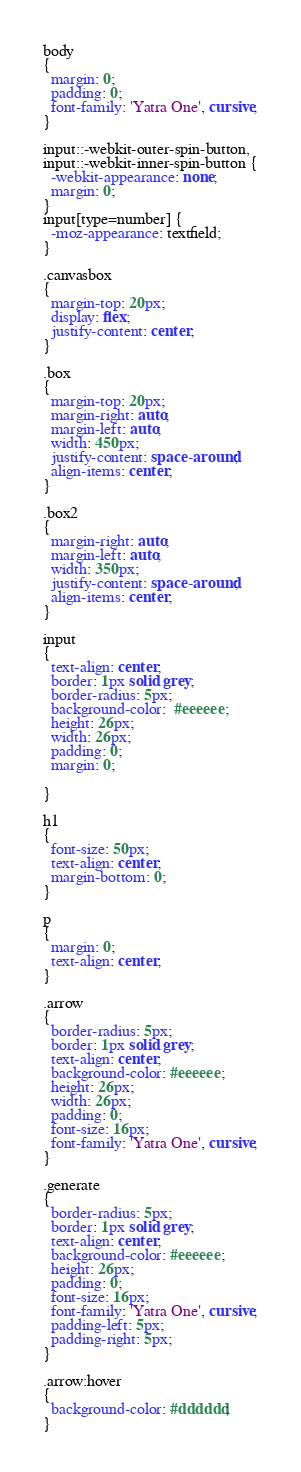Convert code to text. <code><loc_0><loc_0><loc_500><loc_500><_CSS_>body
{
  margin: 0;
  padding: 0;
  font-family: 'Yatra One', cursive;
}

input::-webkit-outer-spin-button,
input::-webkit-inner-spin-button {
  -webkit-appearance: none;
  margin: 0;
}
input[type=number] {
  -moz-appearance: textfield;
}

.canvasbox
{
  margin-top: 20px;
  display: flex;
  justify-content: center;
}

.box
{
  margin-top: 20px;
  margin-right: auto;
  margin-left: auto;
  width: 450px;
  justify-content: space-around;
  align-items: center;
}

.box2
{
  margin-right: auto;
  margin-left: auto;
  width: 350px;
  justify-content: space-around;
  align-items: center;
}

input
{
  text-align: center;
  border: 1px solid grey;
  border-radius: 5px;
  background-color:  #eeeeee;
  height: 26px;
  width: 26px;
  padding: 0;
  margin: 0;

}

h1
{
  font-size: 50px;
  text-align: center;
  margin-bottom: 0;
}

p
{
  margin: 0;
  text-align: center;
}

.arrow
{
  border-radius: 5px;
  border: 1px solid grey;
  text-align: center;
  background-color: #eeeeee;
  height: 26px;
  width: 26px;
  padding: 0;
  font-size: 16px;
  font-family: 'Yatra One', cursive;
}

.generate
{
  border-radius: 5px;
  border: 1px solid grey;
  text-align: center;
  background-color: #eeeeee;
  height: 26px;
  padding: 0;
  font-size: 16px;
  font-family: 'Yatra One', cursive;
  padding-left: 5px;
  padding-right: 5px;
}

.arrow:hover
{
  background-color: #dddddd;
}
</code> 